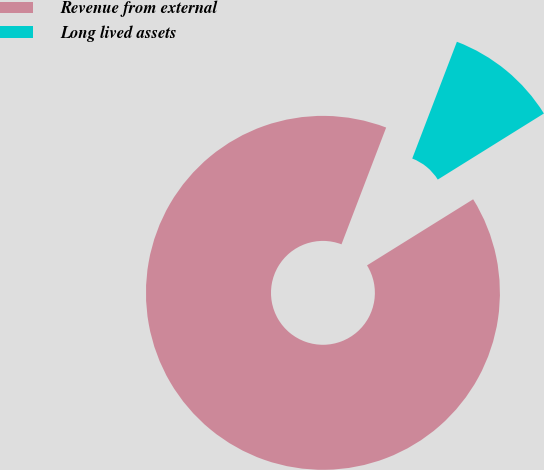Convert chart. <chart><loc_0><loc_0><loc_500><loc_500><pie_chart><fcel>Revenue from external<fcel>Long lived assets<nl><fcel>89.68%<fcel>10.32%<nl></chart> 